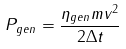Convert formula to latex. <formula><loc_0><loc_0><loc_500><loc_500>P _ { g e n } = \frac { \eta _ { g e n } m v ^ { 2 } } { 2 \Delta t }</formula> 